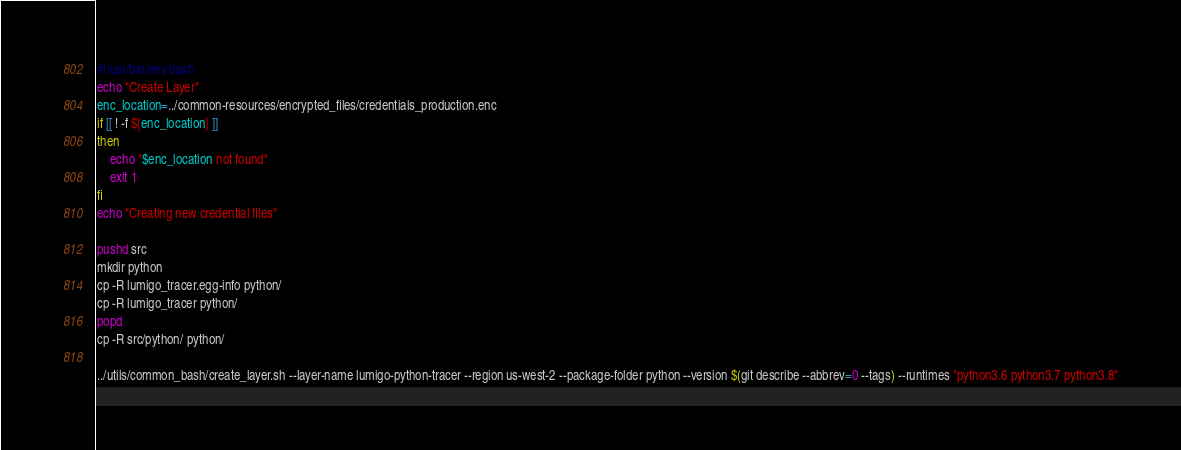<code> <loc_0><loc_0><loc_500><loc_500><_Bash_>#!/usr/bin/env bash
echo "Create Layer"
enc_location=../common-resources/encrypted_files/credentials_production.enc
if [[ ! -f ${enc_location} ]]
then
    echo "$enc_location not found"
    exit 1
fi
echo "Creating new credential files"

pushd src
mkdir python
cp -R lumigo_tracer.egg-info python/
cp -R lumigo_tracer python/
popd
cp -R src/python/ python/

../utils/common_bash/create_layer.sh --layer-name lumigo-python-tracer --region us-west-2 --package-folder python --version $(git describe --abbrev=0 --tags) --runtimes "python3.6 python3.7 python3.8"
</code> 